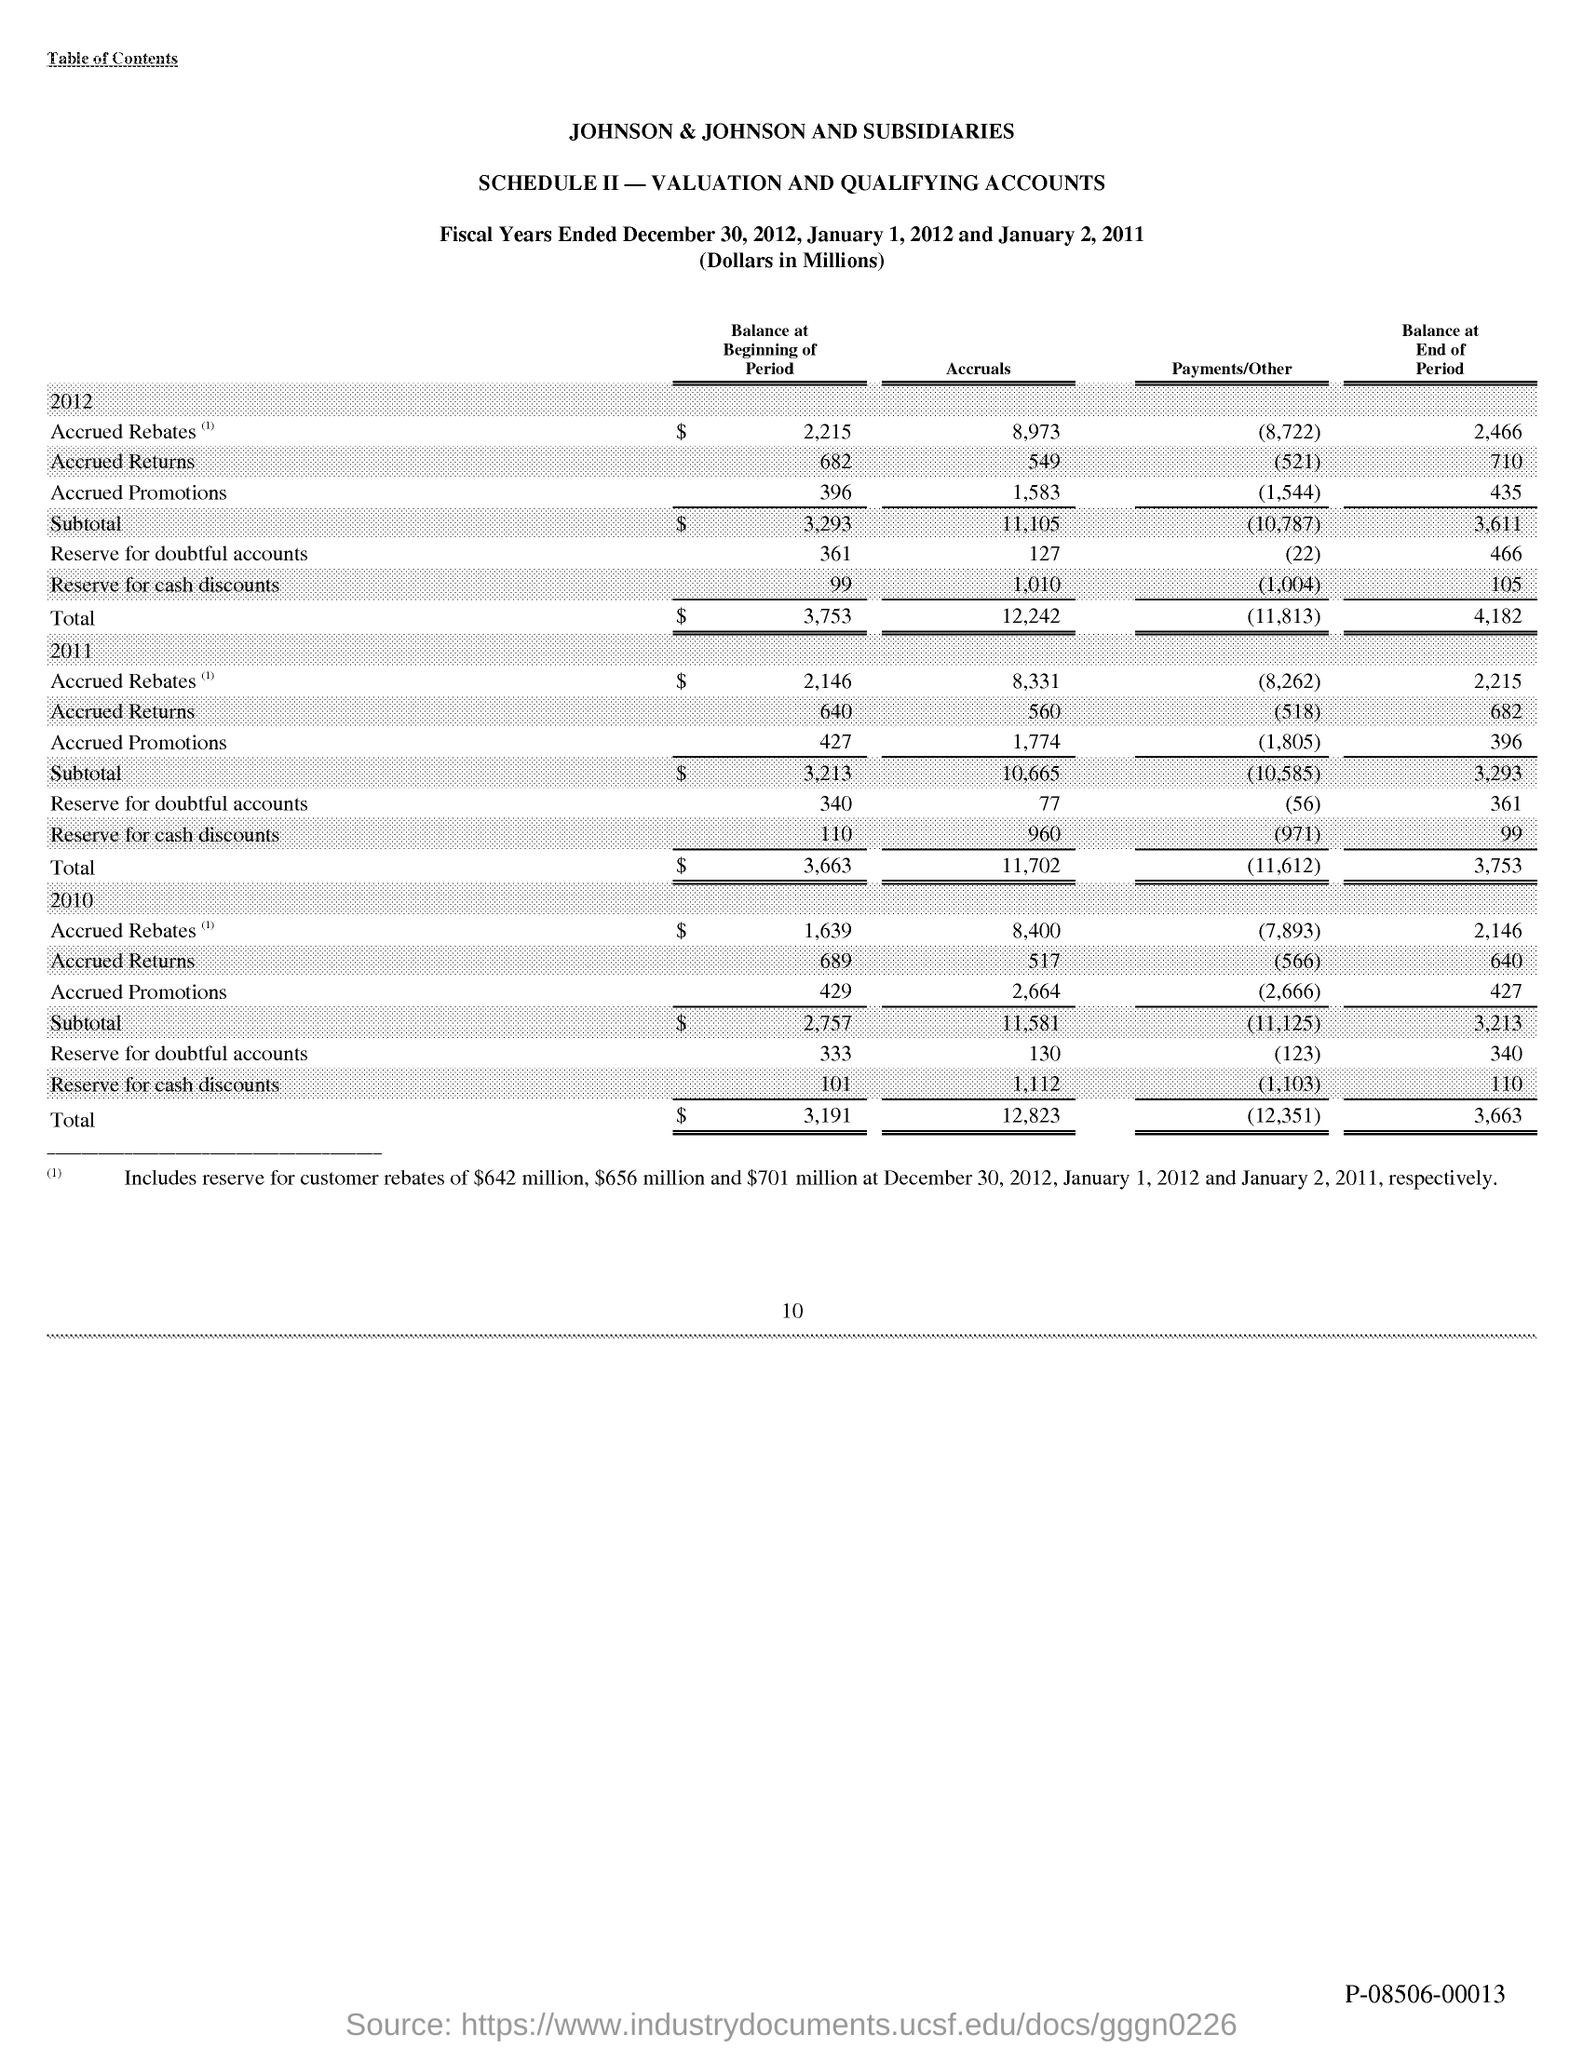What is the Page Number?
Your answer should be compact. 10. 